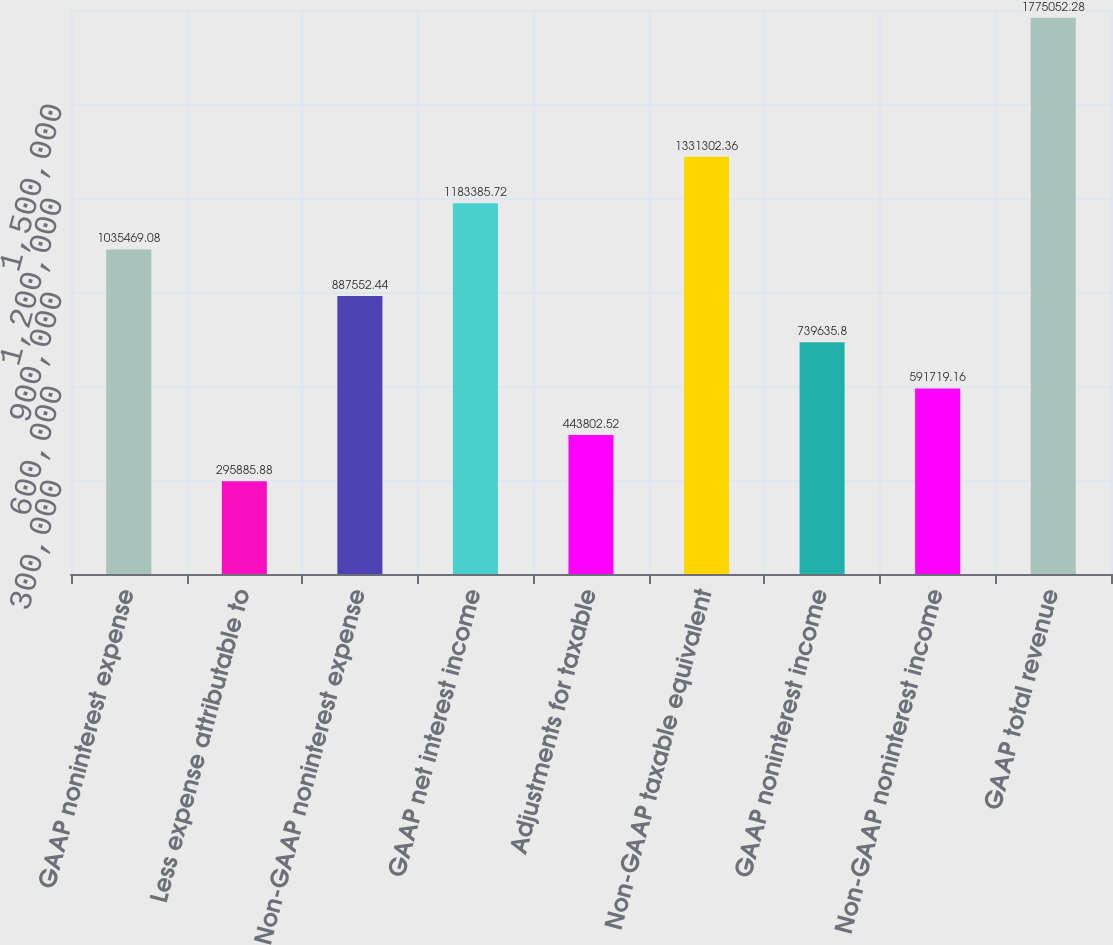Convert chart to OTSL. <chart><loc_0><loc_0><loc_500><loc_500><bar_chart><fcel>GAAP noninterest expense<fcel>Less expense attributable to<fcel>Non-GAAP noninterest expense<fcel>GAAP net interest income<fcel>Adjustments for taxable<fcel>Non-GAAP taxable equivalent<fcel>GAAP noninterest income<fcel>Non-GAAP noninterest income<fcel>GAAP total revenue<nl><fcel>1.03547e+06<fcel>295886<fcel>887552<fcel>1.18339e+06<fcel>443803<fcel>1.3313e+06<fcel>739636<fcel>591719<fcel>1.77505e+06<nl></chart> 